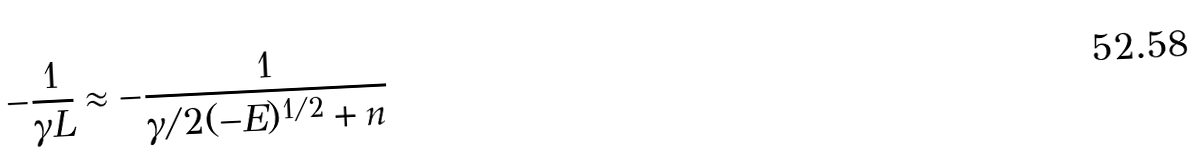Convert formula to latex. <formula><loc_0><loc_0><loc_500><loc_500>- \frac { 1 } { \gamma L } \approx - \frac { 1 } { \gamma / 2 ( - E ) ^ { 1 / 2 } + n }</formula> 